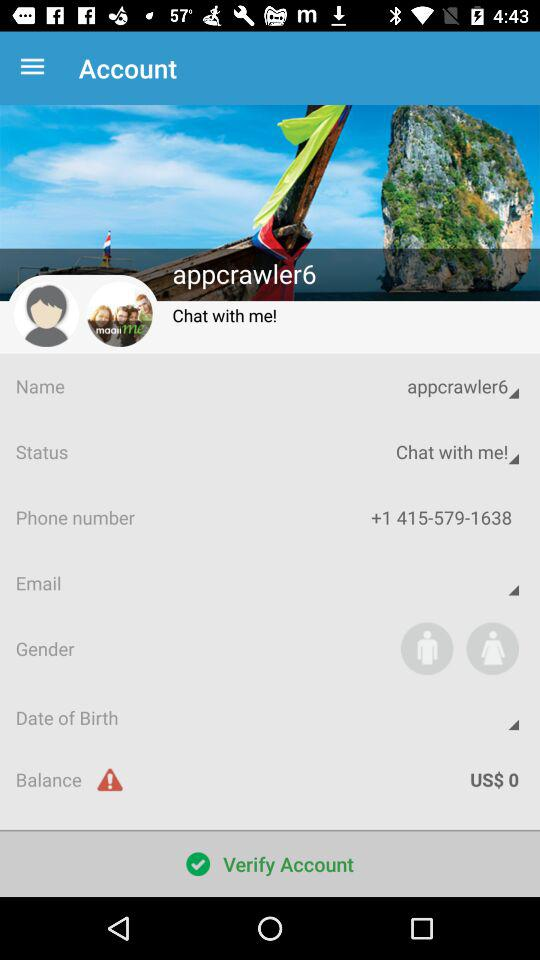What is the name? The name is appcrawler6. 